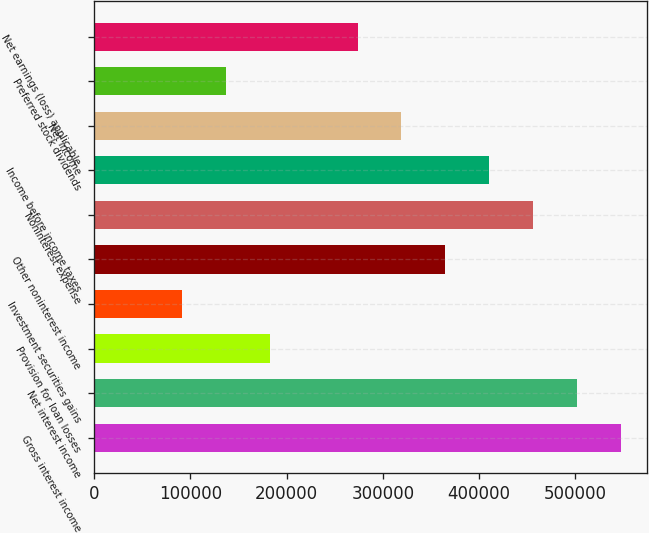Convert chart. <chart><loc_0><loc_0><loc_500><loc_500><bar_chart><fcel>Gross interest income<fcel>Net interest income<fcel>Provision for loan losses<fcel>Investment securities gains<fcel>Other noninterest income<fcel>Noninterest expense<fcel>Income before income taxes<fcel>Net income<fcel>Preferred stock dividends<fcel>Net earnings (loss) applicable<nl><fcel>547476<fcel>501853<fcel>182492<fcel>91246.3<fcel>364984<fcel>456230<fcel>410607<fcel>319361<fcel>136869<fcel>273738<nl></chart> 